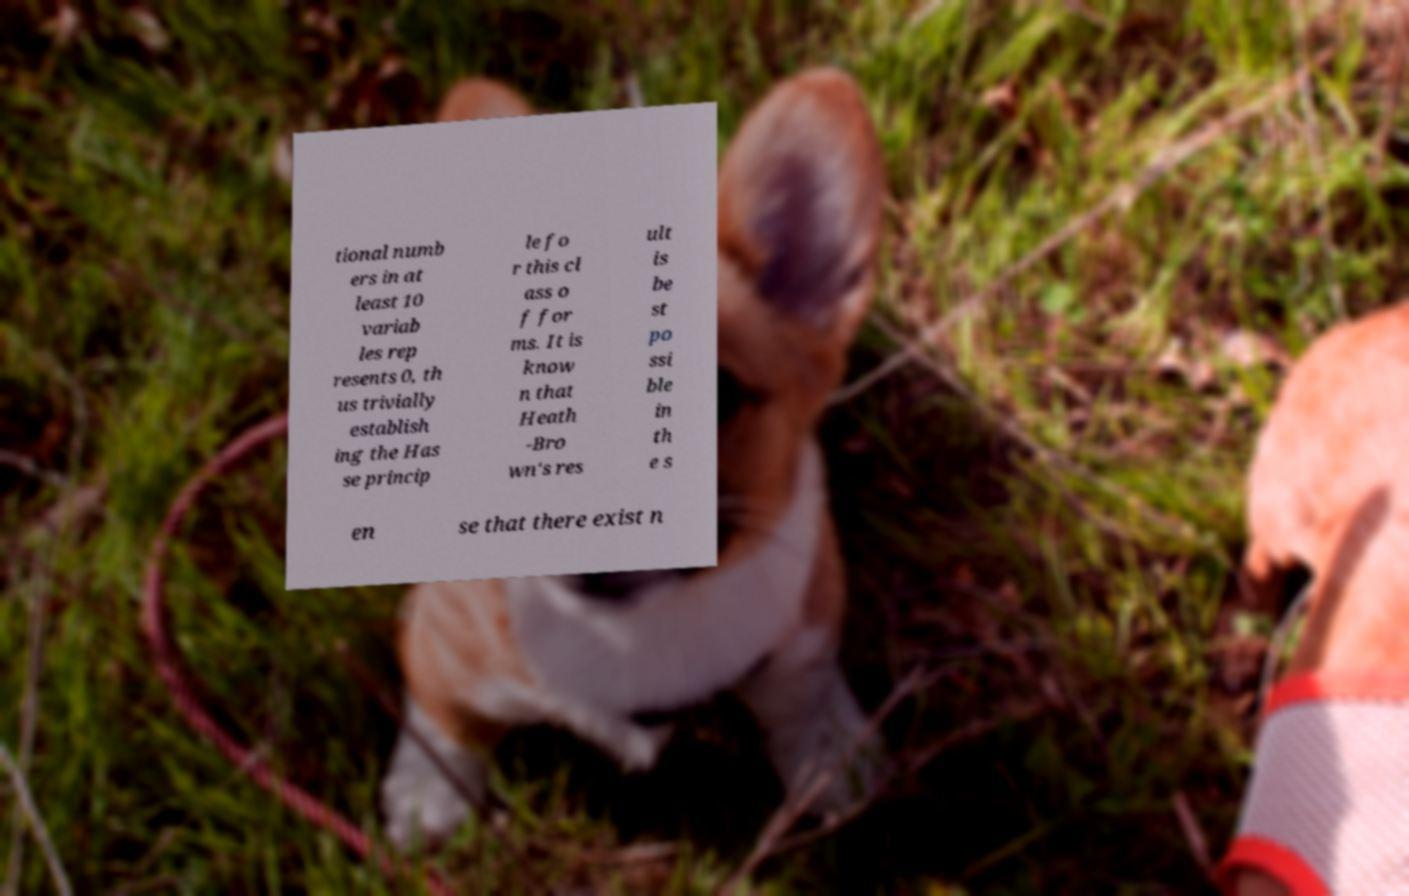There's text embedded in this image that I need extracted. Can you transcribe it verbatim? tional numb ers in at least 10 variab les rep resents 0, th us trivially establish ing the Has se princip le fo r this cl ass o f for ms. It is know n that Heath -Bro wn's res ult is be st po ssi ble in th e s en se that there exist n 